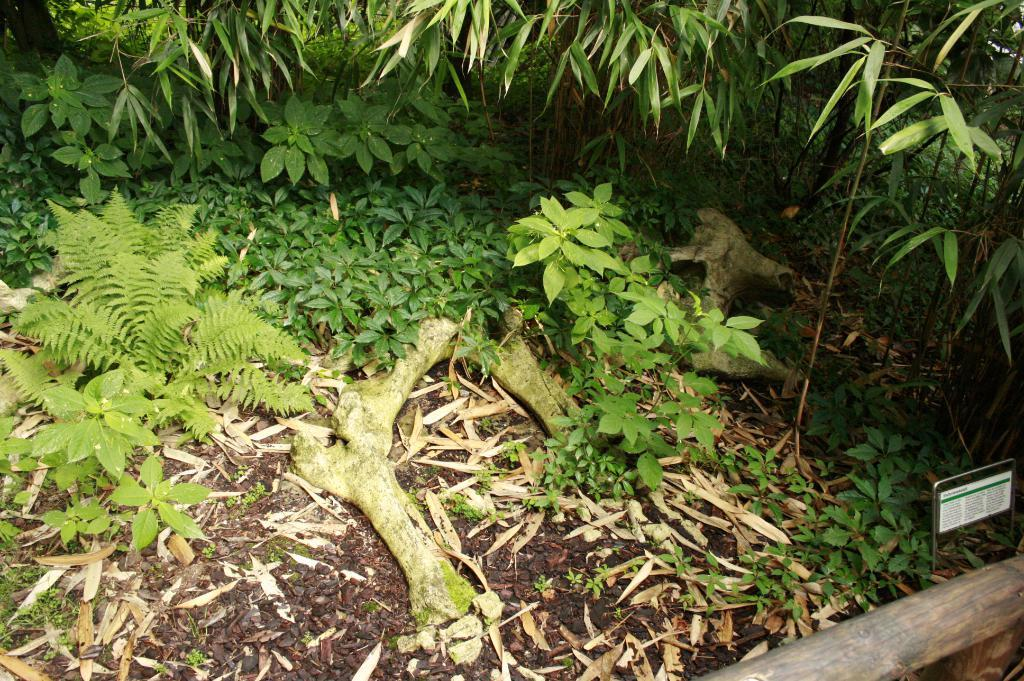What type of natural elements can be seen in the image? There are plants and trees in the image. What can be found on the ground in the image? There are bone-like structures on the ground. Is there any text visible in the image? Yes, there is a metal board with text in the image. How many wrist bones can be seen in the image? There are no wrist bones visible in the image; it features bone-like structures on the ground, but their specific type cannot be determined from the image. 